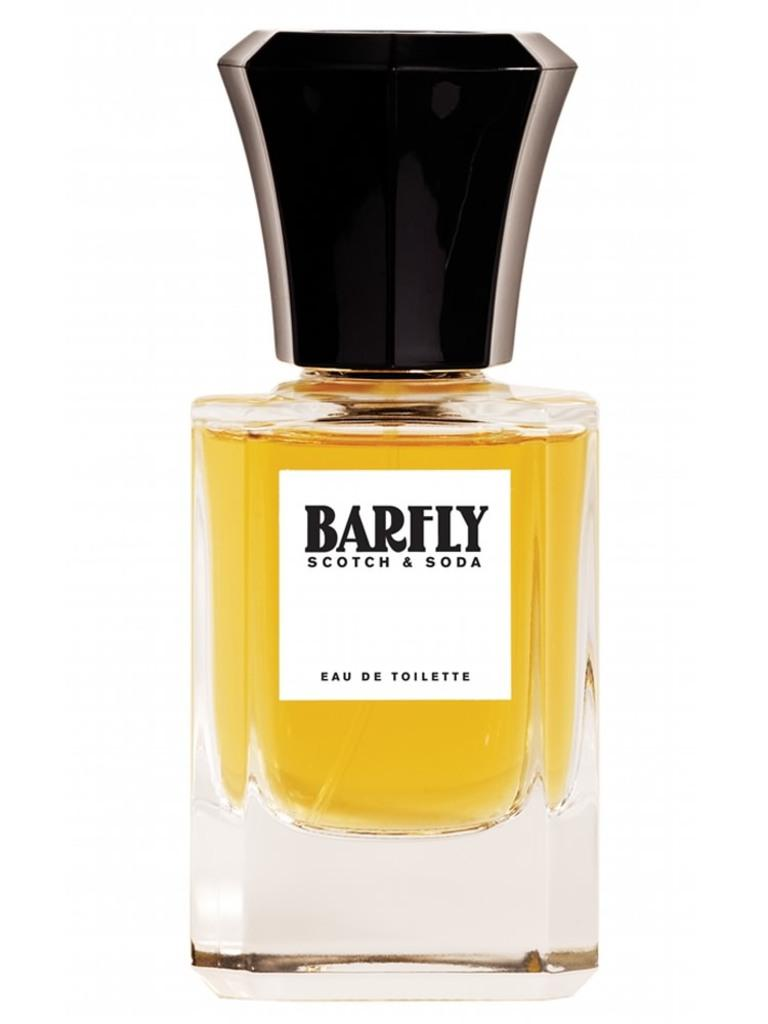<image>
Describe the image concisely. A perfume that is by barfly and the scent is scotch and soda. 